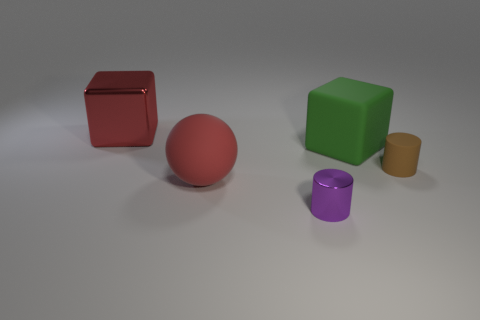There is a sphere that is the same color as the large metal object; what is it made of?
Your answer should be compact. Rubber. There is a large metallic object; is it the same color as the matte object that is to the left of the green object?
Your response must be concise. Yes. The cube on the left side of the purple metallic object that is in front of the block that is to the right of the red metallic thing is made of what material?
Your answer should be very brief. Metal. There is a object that is both behind the ball and to the left of the purple shiny cylinder; what is it made of?
Provide a succinct answer. Metal. What number of other red objects have the same shape as the small rubber object?
Make the answer very short. 0. There is a rubber object that is to the right of the block right of the large red ball; how big is it?
Give a very brief answer. Small. There is a shiny thing behind the green thing; does it have the same color as the big rubber object that is in front of the brown rubber thing?
Keep it short and to the point. Yes. What number of small brown matte objects are to the right of the large red object behind the rubber object in front of the brown matte thing?
Keep it short and to the point. 1. How many objects are behind the red rubber sphere and right of the red rubber object?
Make the answer very short. 2. Are there more large metal cubes that are on the left side of the tiny brown matte object than large gray shiny objects?
Ensure brevity in your answer.  Yes. 